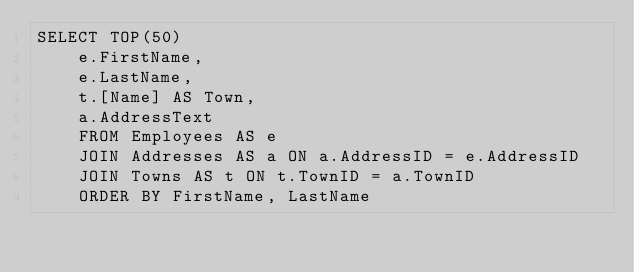<code> <loc_0><loc_0><loc_500><loc_500><_SQL_>SELECT TOP(50)
	e.FirstName,
	e.LastName,
	t.[Name] AS Town,
	a.AddressText
	FROM Employees AS e
	JOIN Addresses AS a ON a.AddressID = e.AddressID
	JOIN Towns AS t ON t.TownID = a.TownID 
	ORDER BY FirstName, LastName</code> 